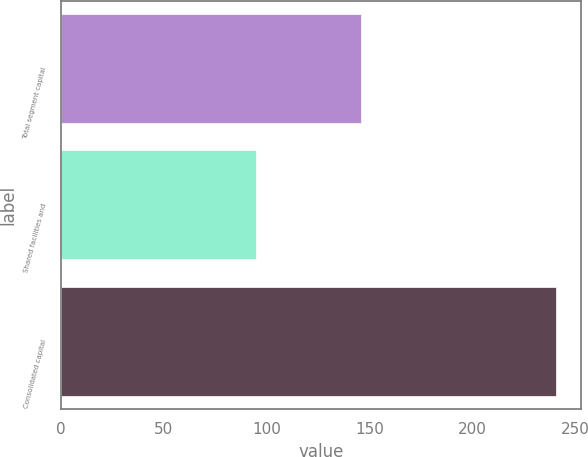Convert chart. <chart><loc_0><loc_0><loc_500><loc_500><bar_chart><fcel>Total segment capital<fcel>Shared facilities and<fcel>Consolidated capital<nl><fcel>146<fcel>95<fcel>241<nl></chart> 